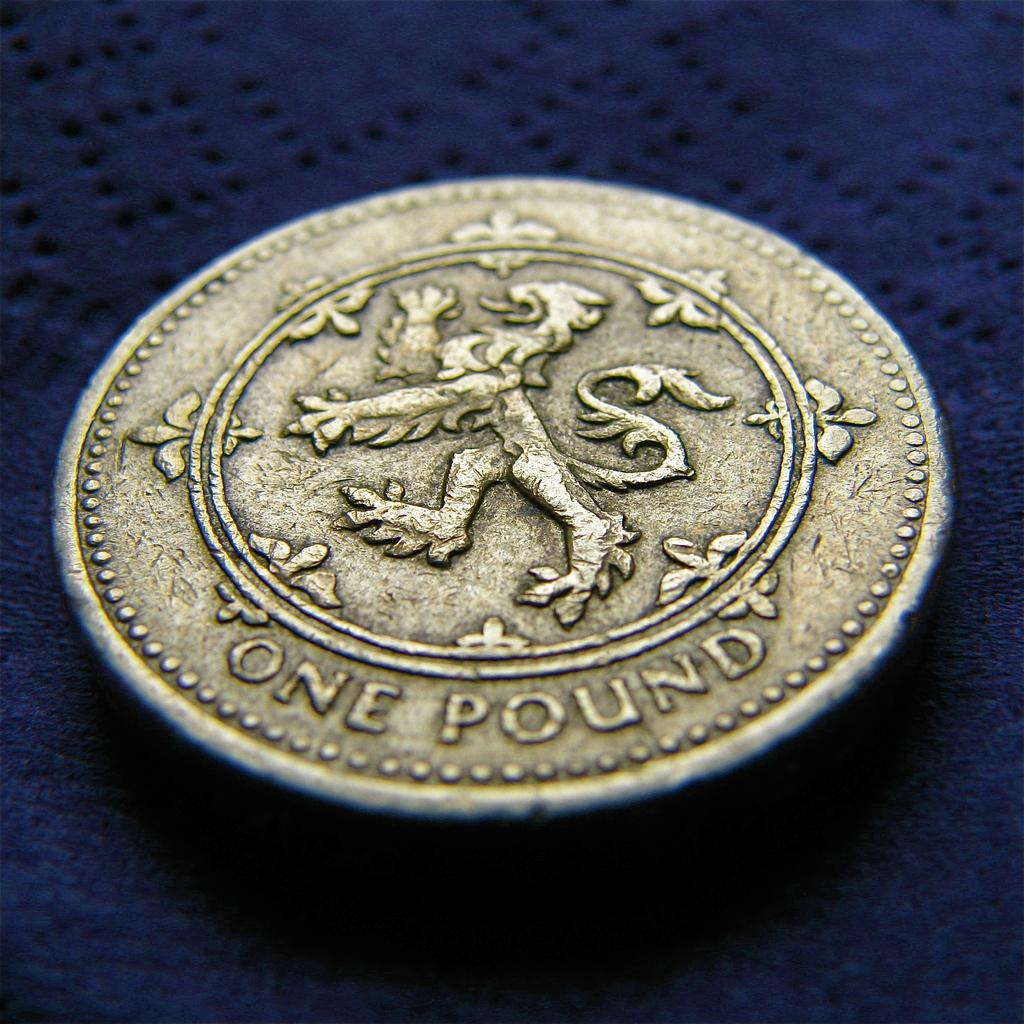<image>
Describe the image concisely. A pound sterling in the form of a golden coin is on top of a blue cloth. 